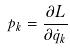Convert formula to latex. <formula><loc_0><loc_0><loc_500><loc_500>p _ { k } = \frac { \partial L } { \partial \dot { q } _ { k } }</formula> 